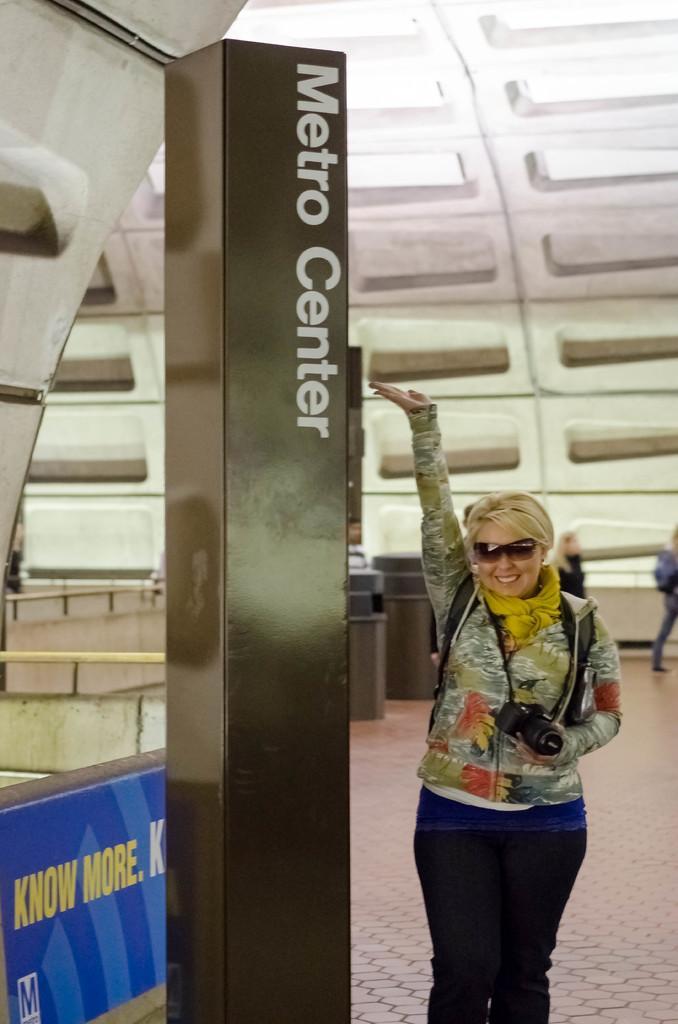Please provide a concise description of this image. In this image I can see a woman is standing by holding the camera in her hand. She wore sweater, in the middle there is the pillar. There is the text on it, on the left side there is the blue color banner. 